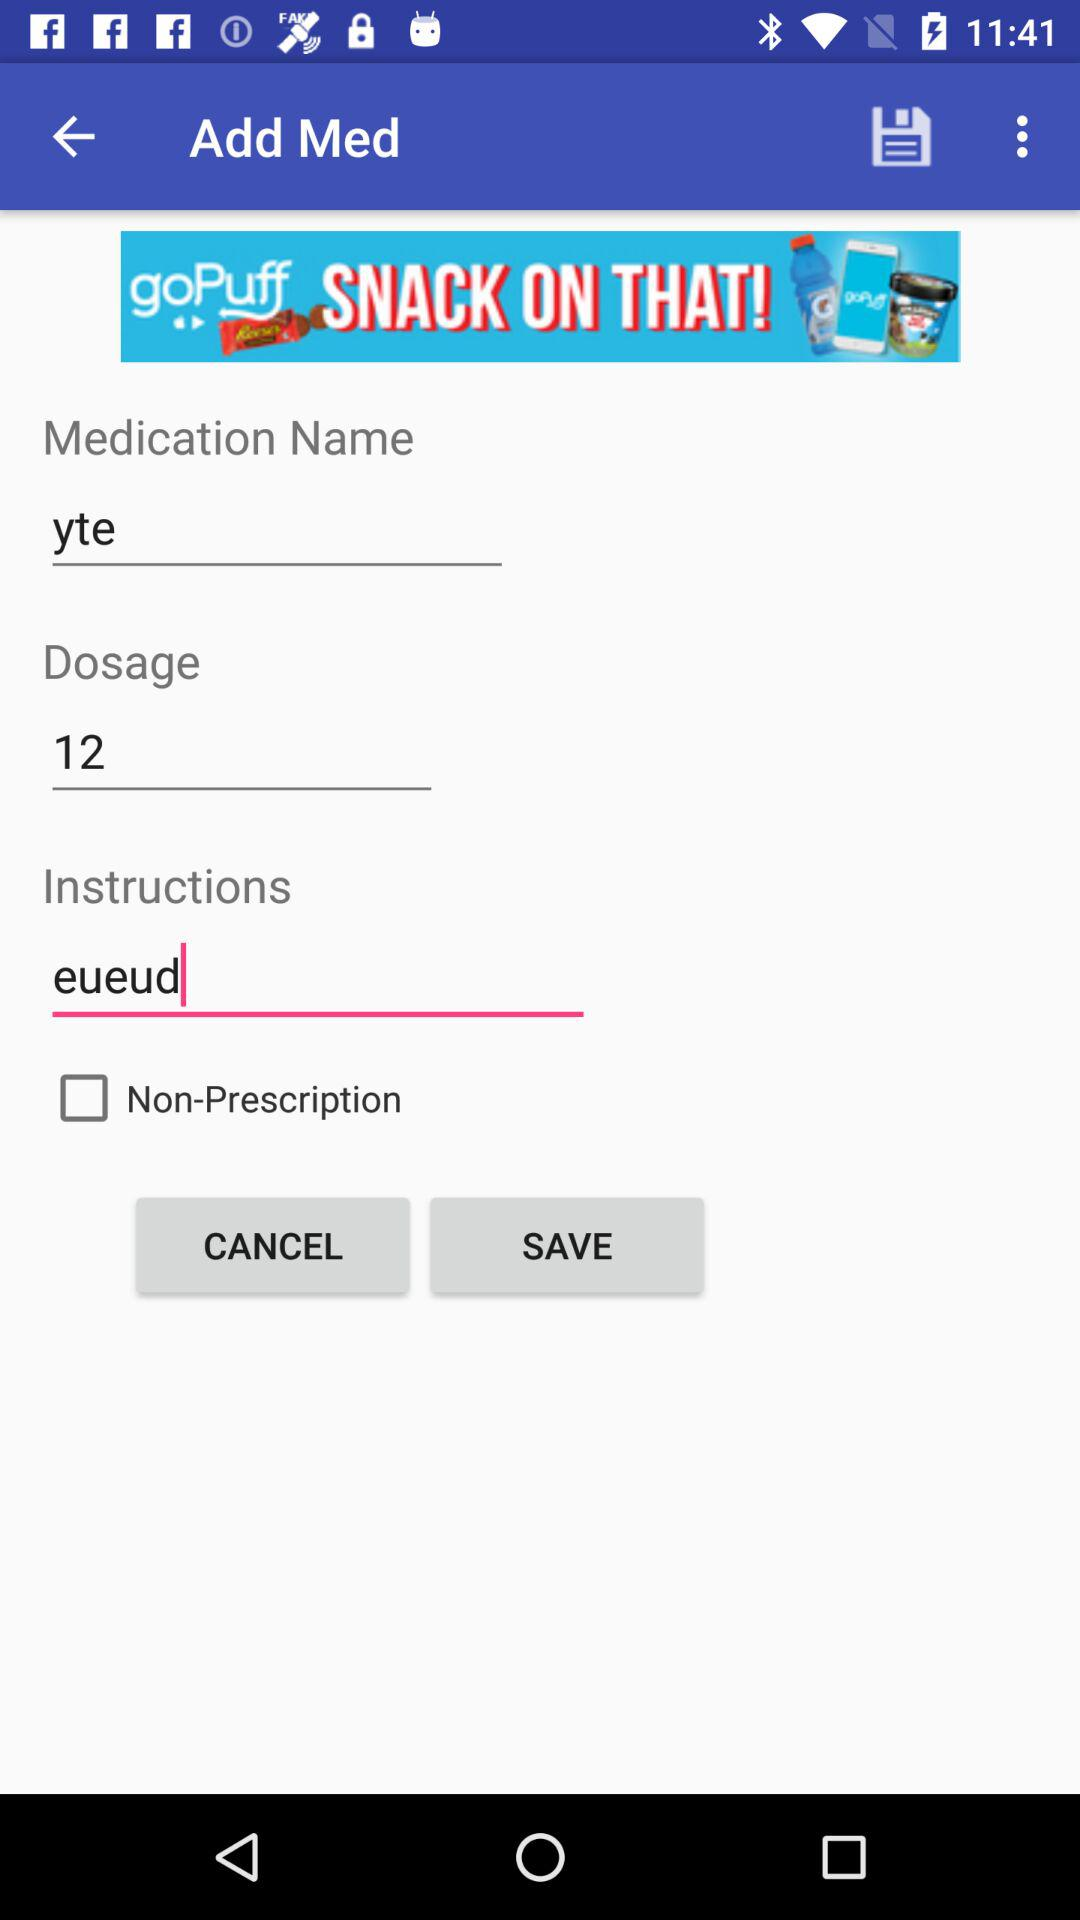What is the medication name? The medication name is "yte". 